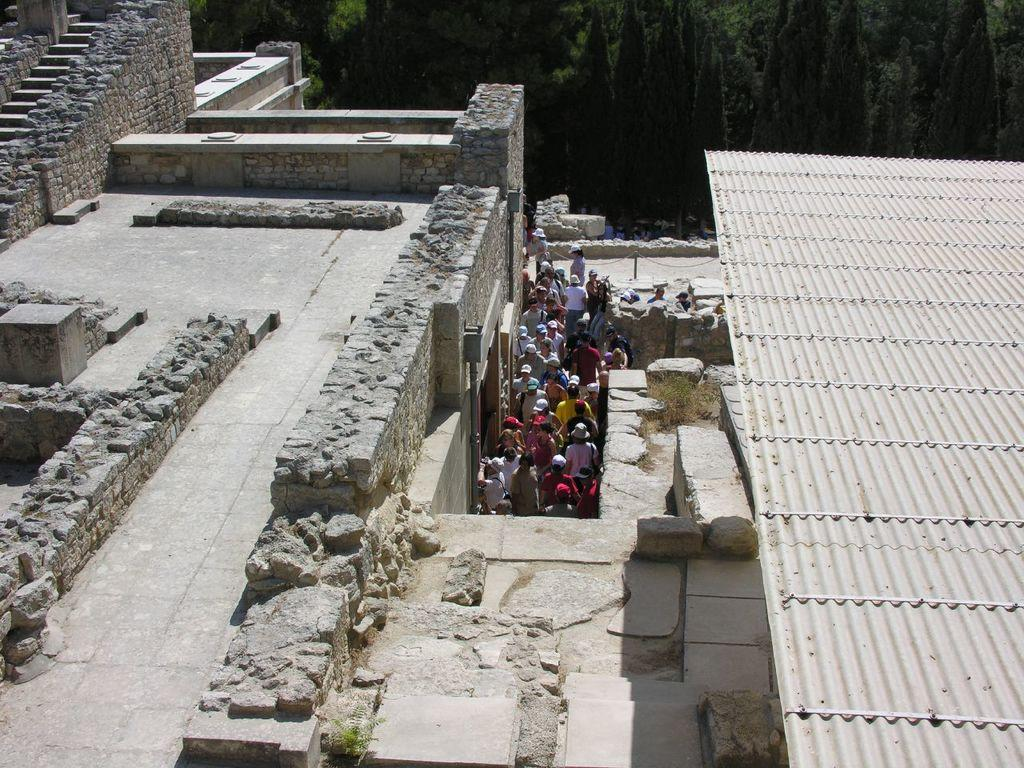What type of structure can be seen in the image? There is a structure that resembles a building in the image. Can you describe what is happening inside the building? There are people inside the building. What is located on the right side of the image? There is a shed on the right side of the image. What can be seen in the background of the image? There are trees in the background of the image. What verse is being recited by the people inside the building in the image? There is no indication in the image that people are reciting a verse, so it cannot be determined from the picture. 